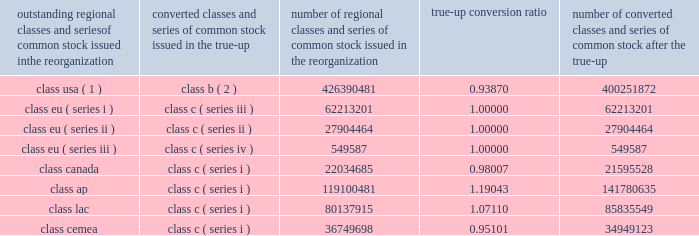Visa inc .
Notes to consolidated financial statements 2014 ( continued ) september 30 , 2008 ( in millions , except as noted ) were converted on a one-to-one basis from class eu ( series i , ii , iii ) common stock to class c ( series iii , ii , and iv ) common stock concurrent with the true-up .
The results of the true-up are reflected in the table below .
Fractional shares resulting from the conversion of the shares of each individual stockholder have been rounded down .
These fractional shares were paid in cash to stockholders as part of the initial redemption of class b common stock and class c common stock shortly following the ipo .
Outstanding regional classes and series of common stock issued in the reorganization converted classes and series of common stock issued in the true-up number of regional classes and series of common stock issued in the reorganization true-up conversion number of converted classes and series of common stock after the true-up class usa ( 1 ) class b ( 2 ) 426390481 0.93870 400251872 .
( 1 ) the amount of the class usa common stock outstanding prior to the true-up is net of 131592008 shares held by wholly-owned subsidiaries of the company .
( 2 ) the amount of the class b common stock outstanding subsequent to the true-up is net of 123525418 shares held by wholly-owned subsidiaries of the company .
Also , the company issued 51844393 additional shares of class c ( series ii ) common stock at a price of $ 44 per share in exchange for a subscription receivable from visa europe .
This issuance and subscription receivable were recorded as offsetting entries in temporary equity on the company 2019s consolidated balance sheet at september 30 , 2008 .
Initial public offering in march 2008 , the company completed its ipo with the issuance of 446600000 shares of class a common stock at a net offering price of $ 42.77 ( the ipo price of $ 44.00 per share of class a common stock , less underwriting discounts and commissions of $ 1.23 per share ) .
The company received net proceeds of $ 19.1 billion as a result of the ipo. .
What amount of net capital was raised by the company at the ipo with the issuance of class a common stock? 
Computations: (446600000 * 42.77)
Answer: 19101082000.0. 